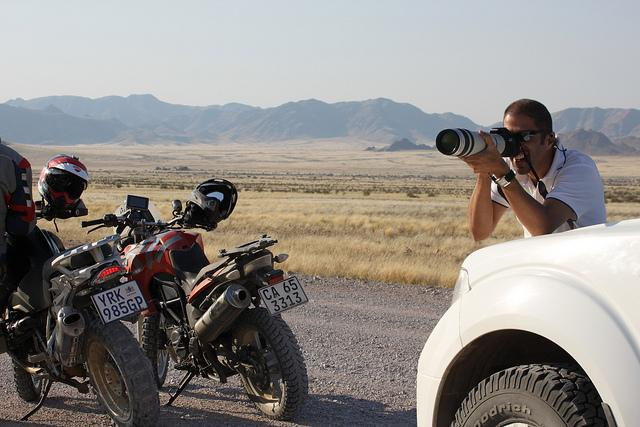How far away is the item being photographed? Please explain your reasoning. very far. The man is using a long lens to photograph something in the distance. 